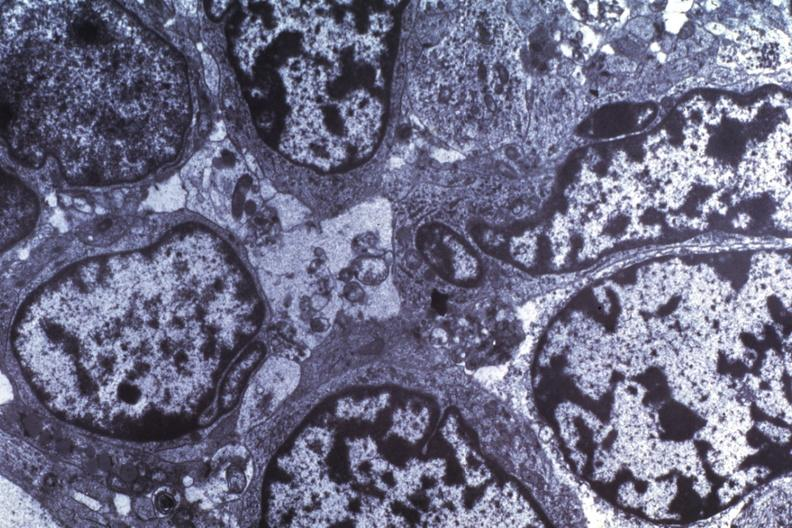s soft tissue present?
Answer the question using a single word or phrase. No 